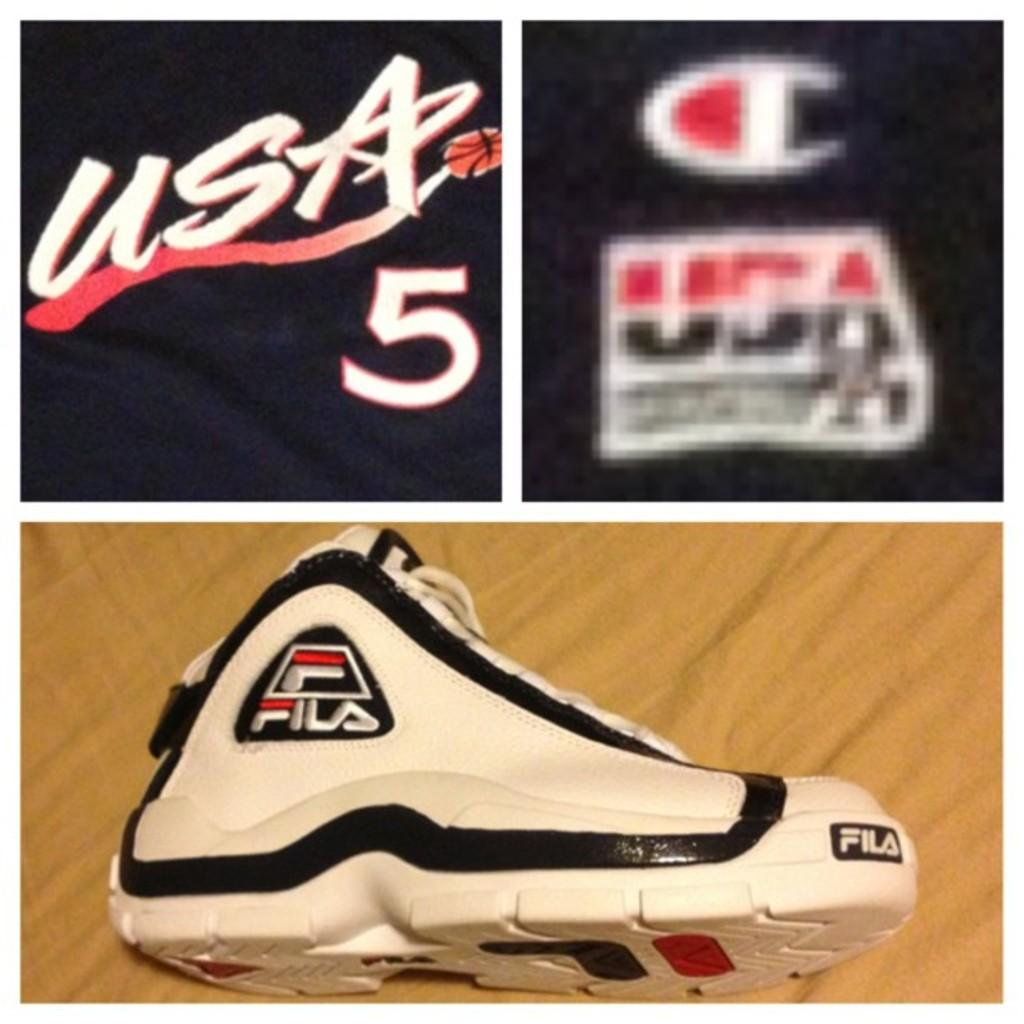Provide a one-sentence caption for the provided image. A Fila shoe and  and a USA 5 emblem on an item that is navy in color. 